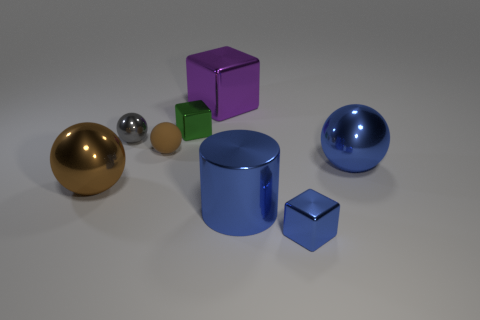Subtract all gray shiny balls. How many balls are left? 3 Add 1 red blocks. How many objects exist? 9 Subtract 1 cylinders. How many cylinders are left? 0 Subtract all yellow cylinders. How many brown spheres are left? 2 Subtract all gray spheres. How many spheres are left? 3 Subtract all cylinders. How many objects are left? 7 Add 4 tiny purple shiny objects. How many tiny purple shiny objects exist? 4 Subtract 0 yellow balls. How many objects are left? 8 Subtract all blue balls. Subtract all purple cylinders. How many balls are left? 3 Subtract all brown metal objects. Subtract all gray shiny spheres. How many objects are left? 6 